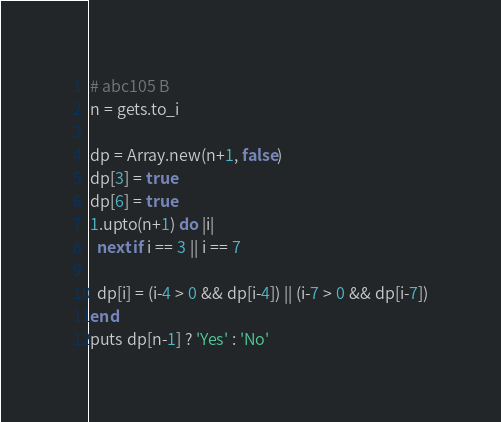Convert code to text. <code><loc_0><loc_0><loc_500><loc_500><_Ruby_># abc105 B
n = gets.to_i

dp = Array.new(n+1, false)
dp[3] = true
dp[6] = true
1.upto(n+1) do |i|
  next if i == 3 || i == 7

  dp[i] = (i-4 > 0 && dp[i-4]) || (i-7 > 0 && dp[i-7])
end
puts dp[n-1] ? 'Yes' : 'No'
</code> 